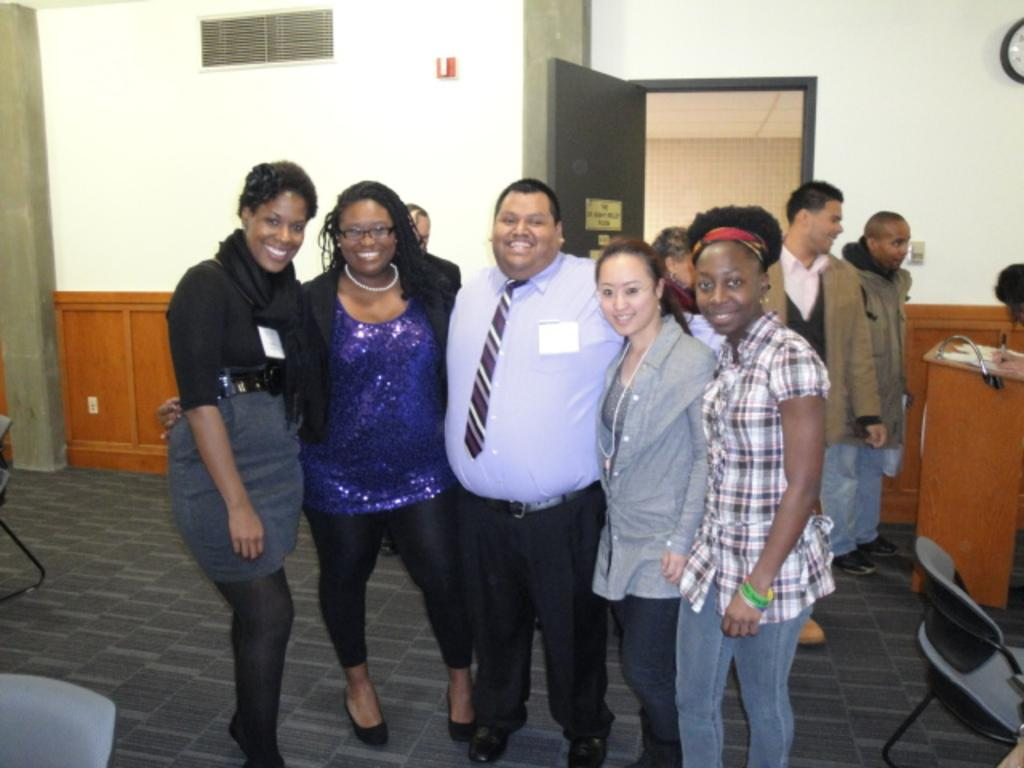What are the people in the image doing? The people in the image are standing in the center. What is located on the right side of the image? There is a podium and chairs on the right side of the image. What can be seen in the background of the image? There is a wall and a door in the background of the image. What scent can be detected in the image? There is no information about any scent in the image. 